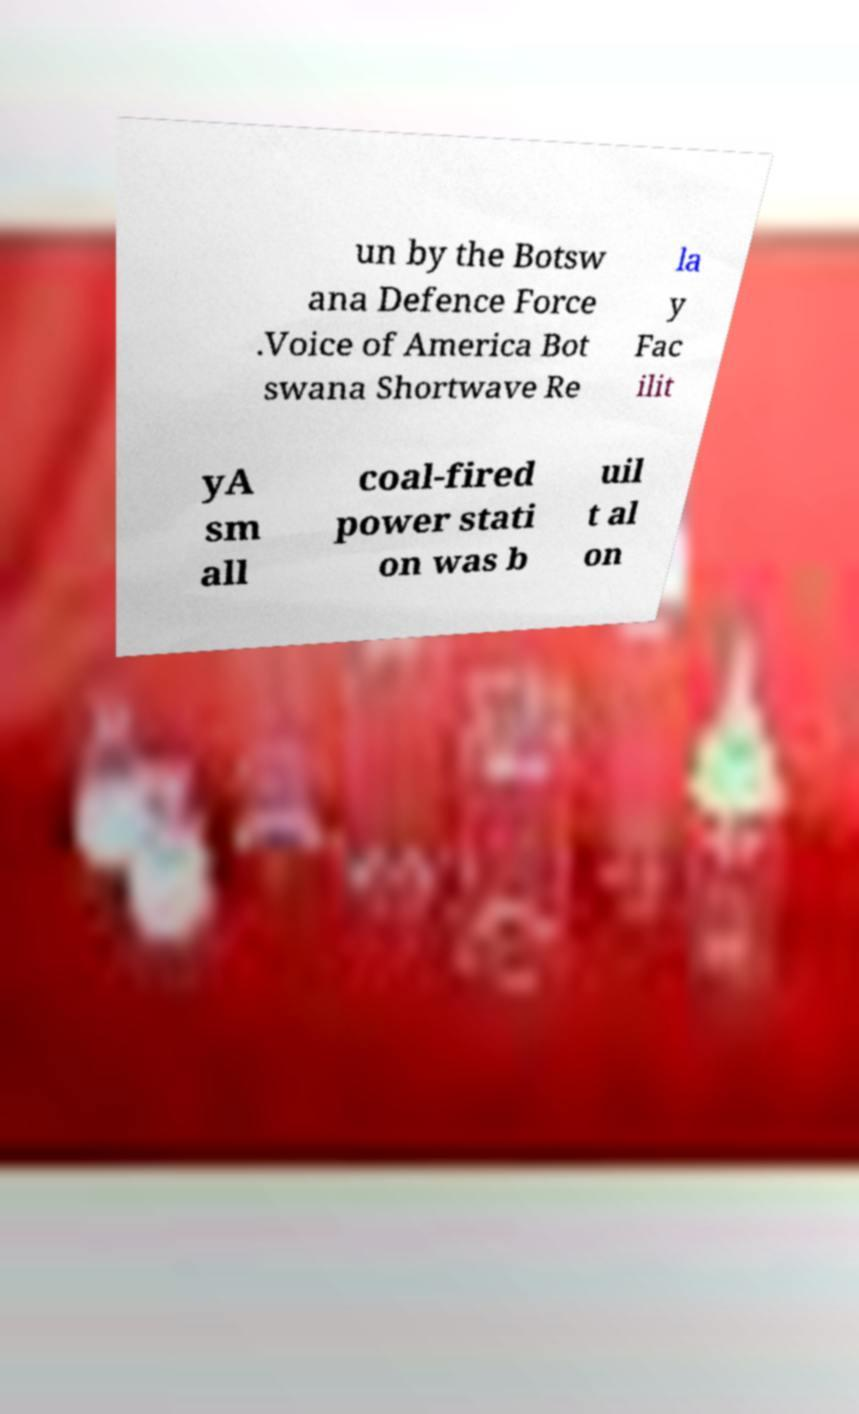Could you assist in decoding the text presented in this image and type it out clearly? un by the Botsw ana Defence Force .Voice of America Bot swana Shortwave Re la y Fac ilit yA sm all coal-fired power stati on was b uil t al on 